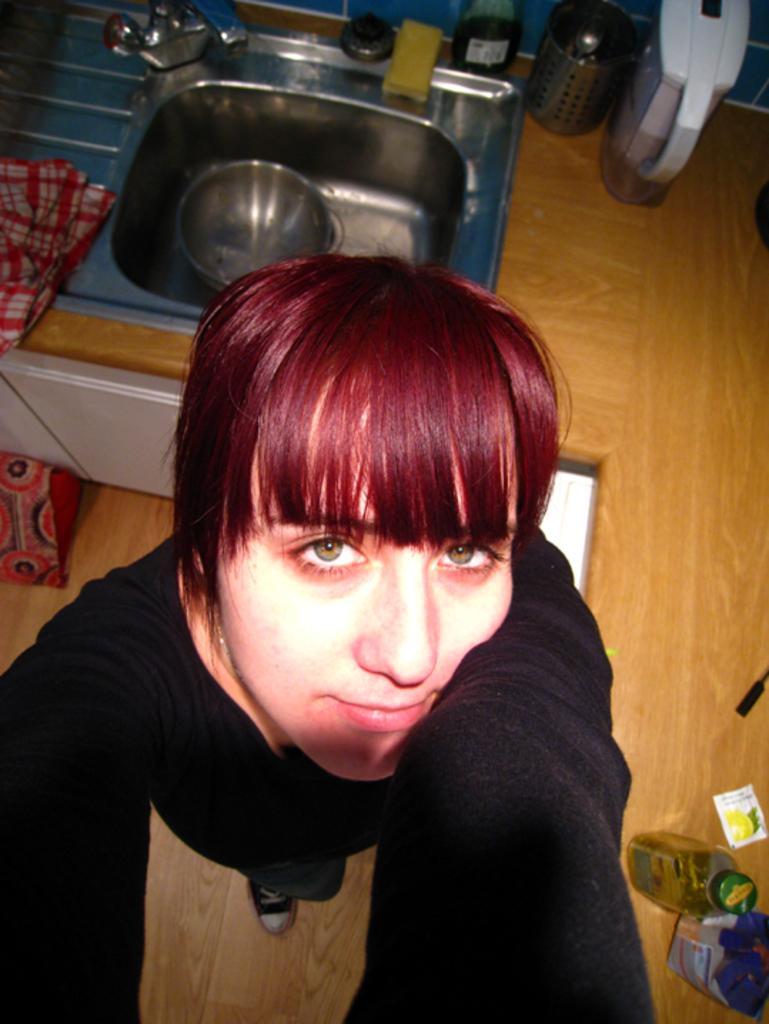In one or two sentences, can you explain what this image depicts? In the image there is a woman in black t-shirt standing in the front and behind there is a wash basin with utensils beside it. 